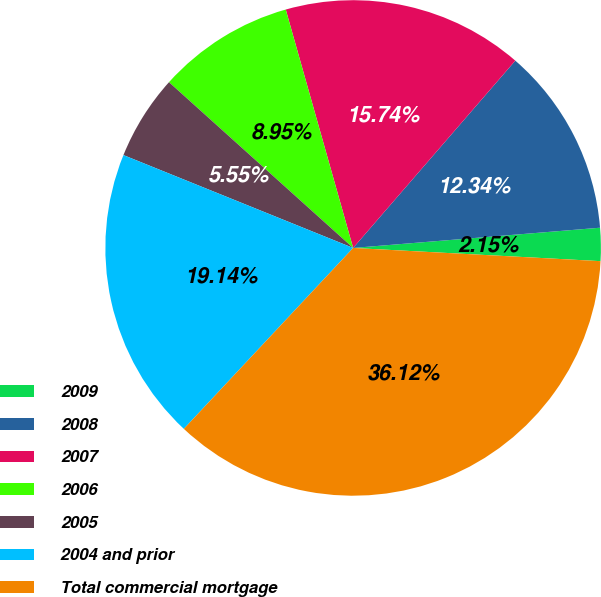<chart> <loc_0><loc_0><loc_500><loc_500><pie_chart><fcel>2009<fcel>2008<fcel>2007<fcel>2006<fcel>2005<fcel>2004 and prior<fcel>Total commercial mortgage<nl><fcel>2.15%<fcel>12.34%<fcel>15.74%<fcel>8.95%<fcel>5.55%<fcel>19.14%<fcel>36.12%<nl></chart> 